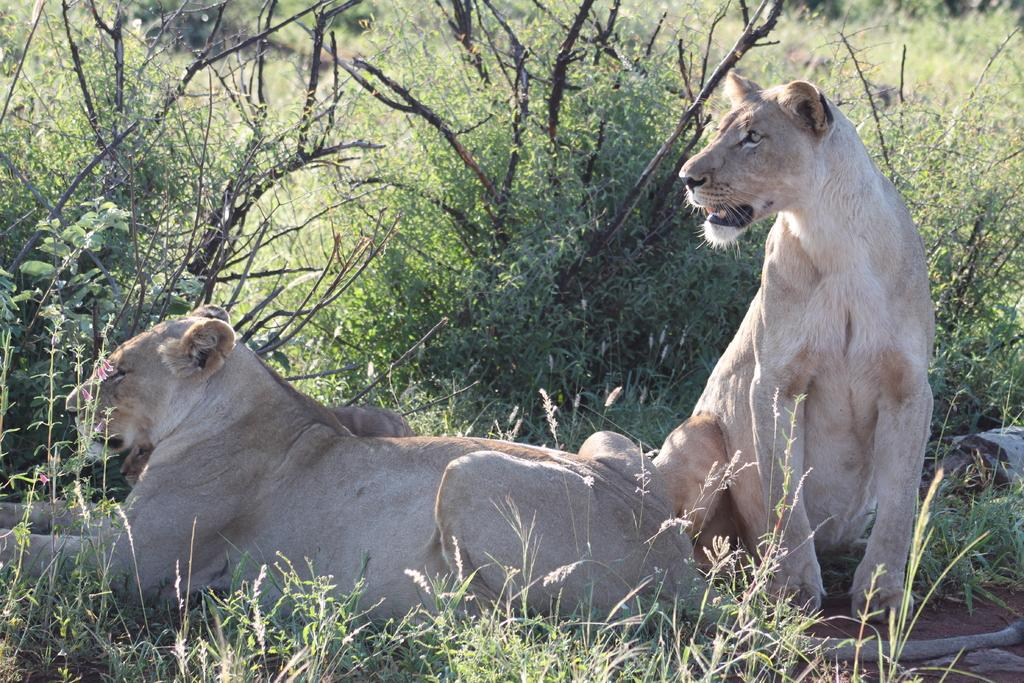What is located in the foreground of the image? There are animals and trees in the foreground of the image. What type of vegetation is visible at the bottom of the image? There is green grass at the bottom of the image. What can be seen in the background of the image? There are trees in the background of the image. What type of cart is being used to transport the animals in the image? There is no cart present in the image; the animals are not being transported. 